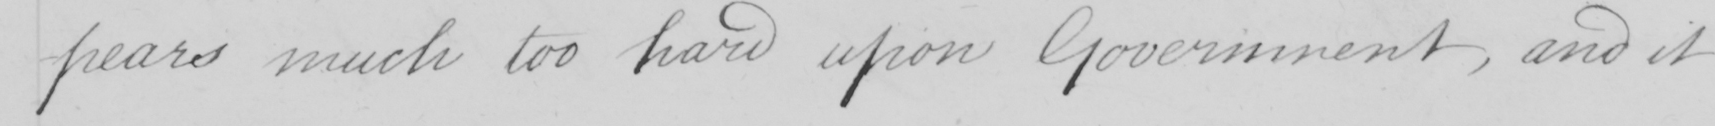Transcribe the text shown in this historical manuscript line. -pears much too hard upon Government , and it 